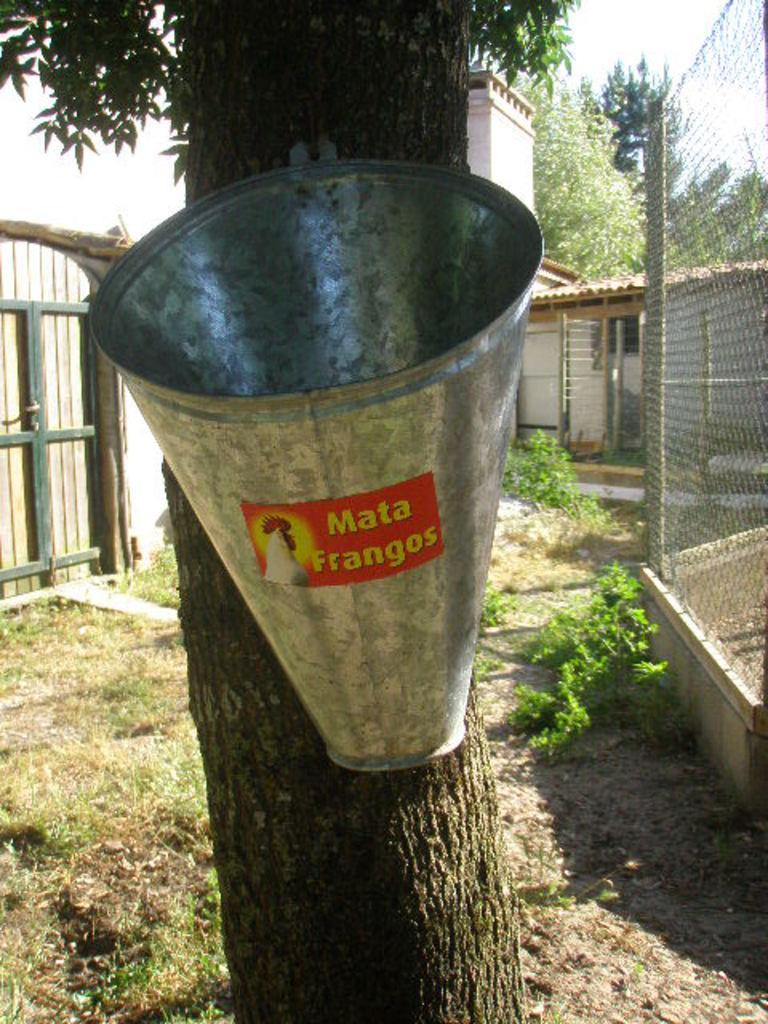In one or two sentences, can you explain what this image depicts? In this image we can see a bucket with a label on it is hanged to the tree. In the background, we can see the grass, plants, fence, wooden door, house and trees and the sky. 